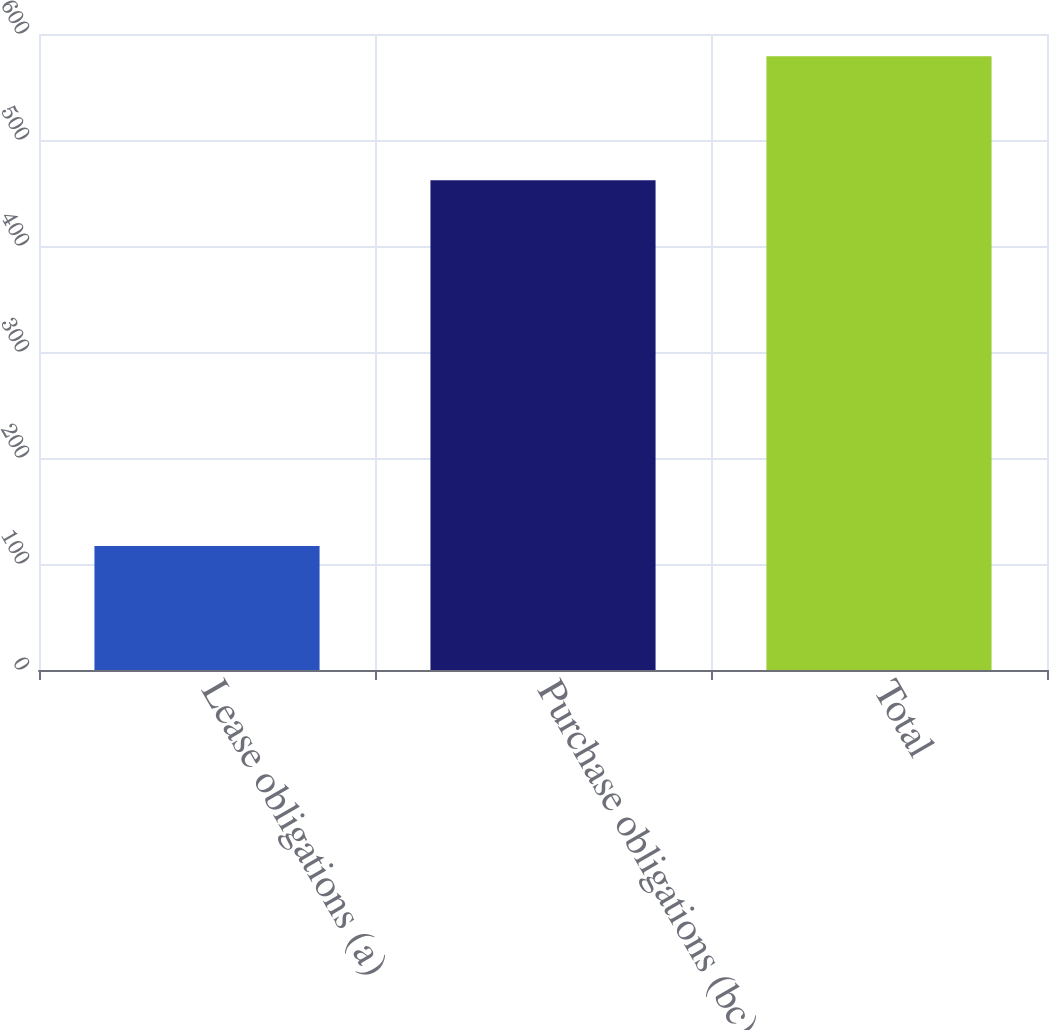Convert chart. <chart><loc_0><loc_0><loc_500><loc_500><bar_chart><fcel>Lease obligations (a)<fcel>Purchase obligations (bc)<fcel>Total<nl><fcel>117<fcel>462<fcel>579<nl></chart> 